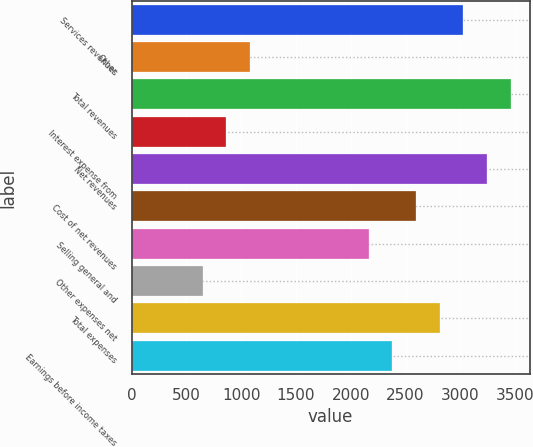Convert chart. <chart><loc_0><loc_0><loc_500><loc_500><bar_chart><fcel>Services revenues<fcel>Other<fcel>Total revenues<fcel>Interest expense from<fcel>Net revenues<fcel>Cost of net revenues<fcel>Selling general and<fcel>Other expenses net<fcel>Total expenses<fcel>Earnings before income taxes<nl><fcel>3027.7<fcel>1081.36<fcel>3460.22<fcel>865.1<fcel>3243.96<fcel>2595.18<fcel>2162.66<fcel>648.84<fcel>2811.44<fcel>2378.92<nl></chart> 